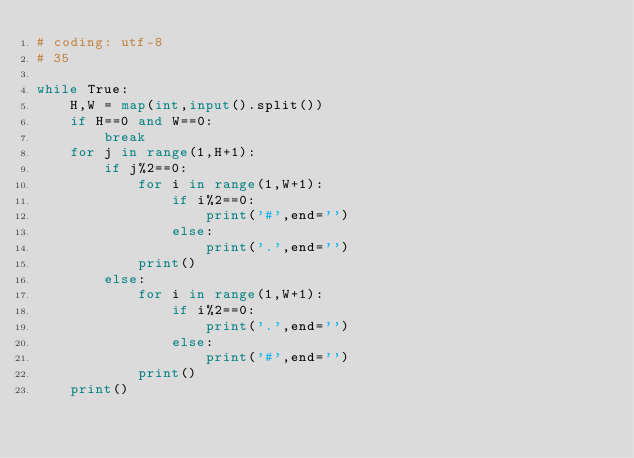Convert code to text. <code><loc_0><loc_0><loc_500><loc_500><_Python_># coding: utf-8
# 35

while True:
    H,W = map(int,input().split())
    if H==0 and W==0:
        break
    for j in range(1,H+1):
        if j%2==0:
            for i in range(1,W+1):
                if i%2==0:
                    print('#',end='')
                else:
                    print('.',end='')
            print()
        else:
            for i in range(1,W+1):
                if i%2==0:
                    print('.',end='')
                else:
                    print('#',end='')
            print()
    print()
    

</code> 